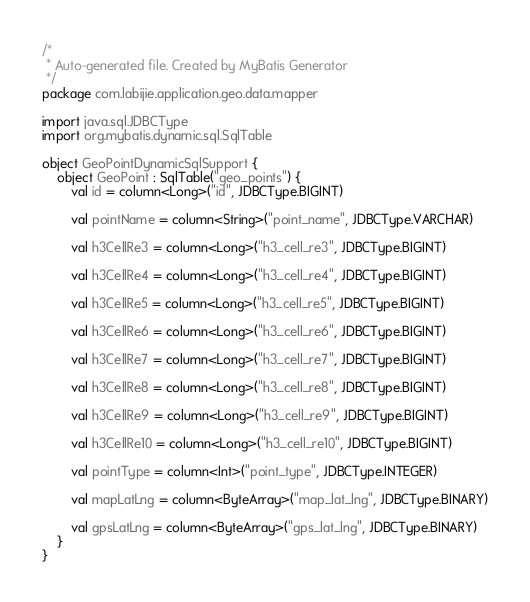Convert code to text. <code><loc_0><loc_0><loc_500><loc_500><_Kotlin_>/*
 * Auto-generated file. Created by MyBatis Generator
 */
package com.labijie.application.geo.data.mapper

import java.sql.JDBCType
import org.mybatis.dynamic.sql.SqlTable

object GeoPointDynamicSqlSupport {
    object GeoPoint : SqlTable("geo_points") {
        val id = column<Long>("id", JDBCType.BIGINT)

        val pointName = column<String>("point_name", JDBCType.VARCHAR)

        val h3CellRe3 = column<Long>("h3_cell_re3", JDBCType.BIGINT)

        val h3CellRe4 = column<Long>("h3_cell_re4", JDBCType.BIGINT)

        val h3CellRe5 = column<Long>("h3_cell_re5", JDBCType.BIGINT)

        val h3CellRe6 = column<Long>("h3_cell_re6", JDBCType.BIGINT)

        val h3CellRe7 = column<Long>("h3_cell_re7", JDBCType.BIGINT)

        val h3CellRe8 = column<Long>("h3_cell_re8", JDBCType.BIGINT)

        val h3CellRe9 = column<Long>("h3_cell_re9", JDBCType.BIGINT)

        val h3CellRe10 = column<Long>("h3_cell_re10", JDBCType.BIGINT)

        val pointType = column<Int>("point_type", JDBCType.INTEGER)

        val mapLatLng = column<ByteArray>("map_lat_lng", JDBCType.BINARY)

        val gpsLatLng = column<ByteArray>("gps_lat_lng", JDBCType.BINARY)
    }
}</code> 